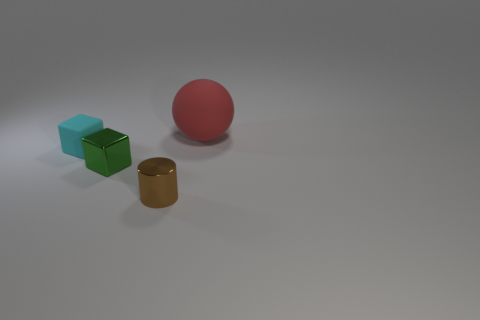What is the color of the matte object that is right of the cube on the right side of the matte object that is to the left of the big object?
Keep it short and to the point. Red. Does the cyan thing have the same material as the tiny thing in front of the tiny green block?
Make the answer very short. No. What material is the big thing?
Ensure brevity in your answer.  Rubber. What number of other objects are the same material as the large red sphere?
Ensure brevity in your answer.  1. There is a object that is both behind the green metallic object and in front of the big red thing; what is its shape?
Provide a succinct answer. Cube. There is a small thing that is the same material as the large red thing; what color is it?
Keep it short and to the point. Cyan. Are there the same number of tiny things right of the red rubber ball and tiny red blocks?
Your answer should be compact. Yes. What shape is the brown object that is the same size as the green metal object?
Keep it short and to the point. Cylinder. How many other things are there of the same shape as the large red matte thing?
Keep it short and to the point. 0. Do the cyan matte object and the metal thing that is in front of the tiny metallic cube have the same size?
Make the answer very short. Yes. 